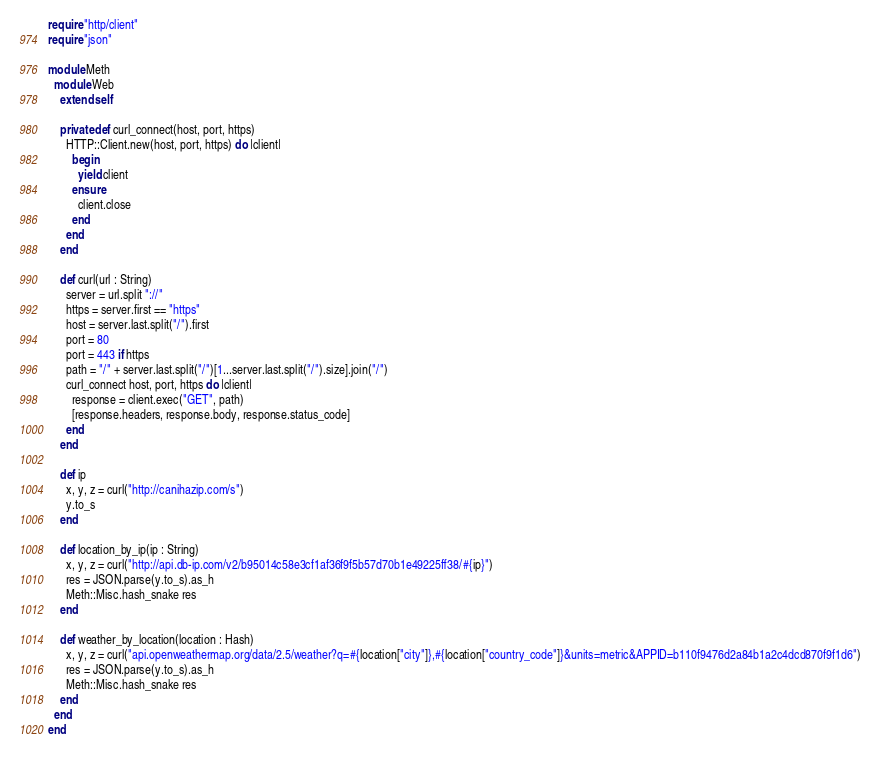Convert code to text. <code><loc_0><loc_0><loc_500><loc_500><_Crystal_>require "http/client"
require "json"

module Meth
  module Web
    extend self

    private def curl_connect(host, port, https)
      HTTP::Client.new(host, port, https) do |client|
        begin
          yield client
        ensure
          client.close
        end
      end
    end

    def curl(url : String)
      server = url.split "://"
      https = server.first == "https"
      host = server.last.split("/").first
      port = 80
      port = 443 if https
      path = "/" + server.last.split("/")[1...server.last.split("/").size].join("/")
      curl_connect host, port, https do |client|
        response = client.exec("GET", path)
        [response.headers, response.body, response.status_code]
      end
    end

    def ip
      x, y, z = curl("http://canihazip.com/s")
      y.to_s
    end

    def location_by_ip(ip : String)
      x, y, z = curl("http://api.db-ip.com/v2/b95014c58e3cf1af36f9f5b57d70b1e49225ff38/#{ip}")
      res = JSON.parse(y.to_s).as_h
      Meth::Misc.hash_snake res
    end

    def weather_by_location(location : Hash)
      x, y, z = curl("api.openweathermap.org/data/2.5/weather?q=#{location["city"]},#{location["country_code"]}&units=metric&APPID=b110f9476d2a84b1a2c4dcd870f9f1d6")
      res = JSON.parse(y.to_s).as_h
      Meth::Misc.hash_snake res
    end
  end
end
</code> 